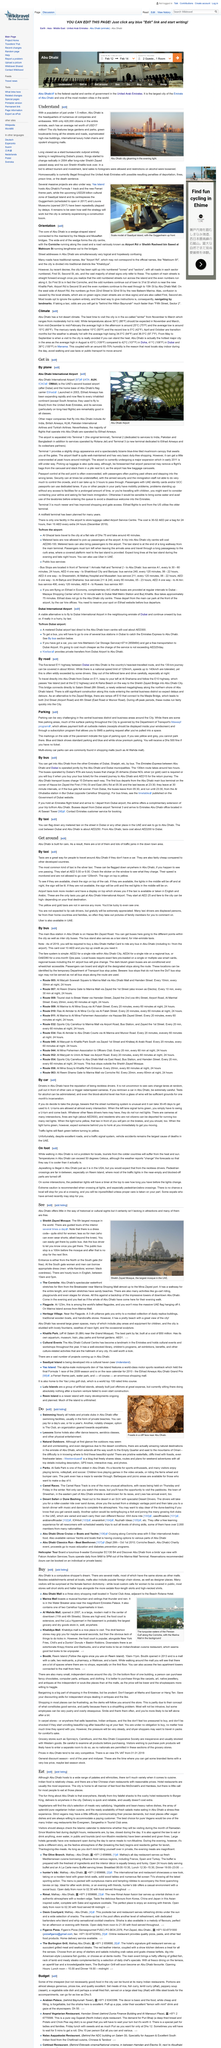Outline some significant characteristics in this image. The average net worth of each citizen in the emirate is approximately 17 million dollars. The picture depicts Abu Dhabi's high-rise buildings of various kinds, showcasing the city's modern and developed architectural landscape. There are three terminals at Abu Dhabi Airport. Abu Dhabi is the city that serves as the headquarters of oil companies and embassies in the United Arab Emirates. Yes, there is an international airport in Abu Dhabi from which travelers can arrive by plane. It is called Abu Dhabi International Airport. 